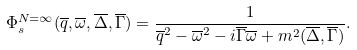Convert formula to latex. <formula><loc_0><loc_0><loc_500><loc_500>\Phi _ { s } ^ { N = \infty } ( \overline { q } , \overline { \omega } , \overline { \Delta } , \overline { \Gamma } ) = \frac { 1 } { \overline { q } ^ { 2 } - \overline { \omega } ^ { 2 } - i \overline { \Gamma } \overline { \omega } + m ^ { 2 } ( \overline { \Delta } , \overline { \Gamma } ) } .</formula> 